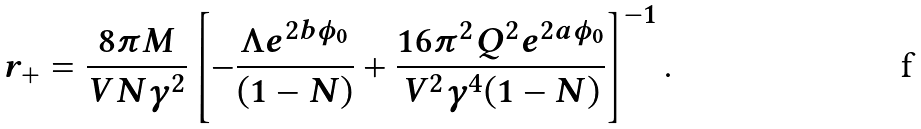Convert formula to latex. <formula><loc_0><loc_0><loc_500><loc_500>r _ { + } = \frac { 8 \pi M } { V N \gamma ^ { 2 } } \left [ - \frac { \Lambda e ^ { 2 b \phi _ { 0 } } } { ( 1 - N ) } + \frac { 1 6 \pi ^ { 2 } Q ^ { 2 } e ^ { 2 a \phi _ { 0 } } } { V ^ { 2 } \gamma ^ { 4 } ( 1 - N ) } \right ] ^ { - 1 } .</formula> 